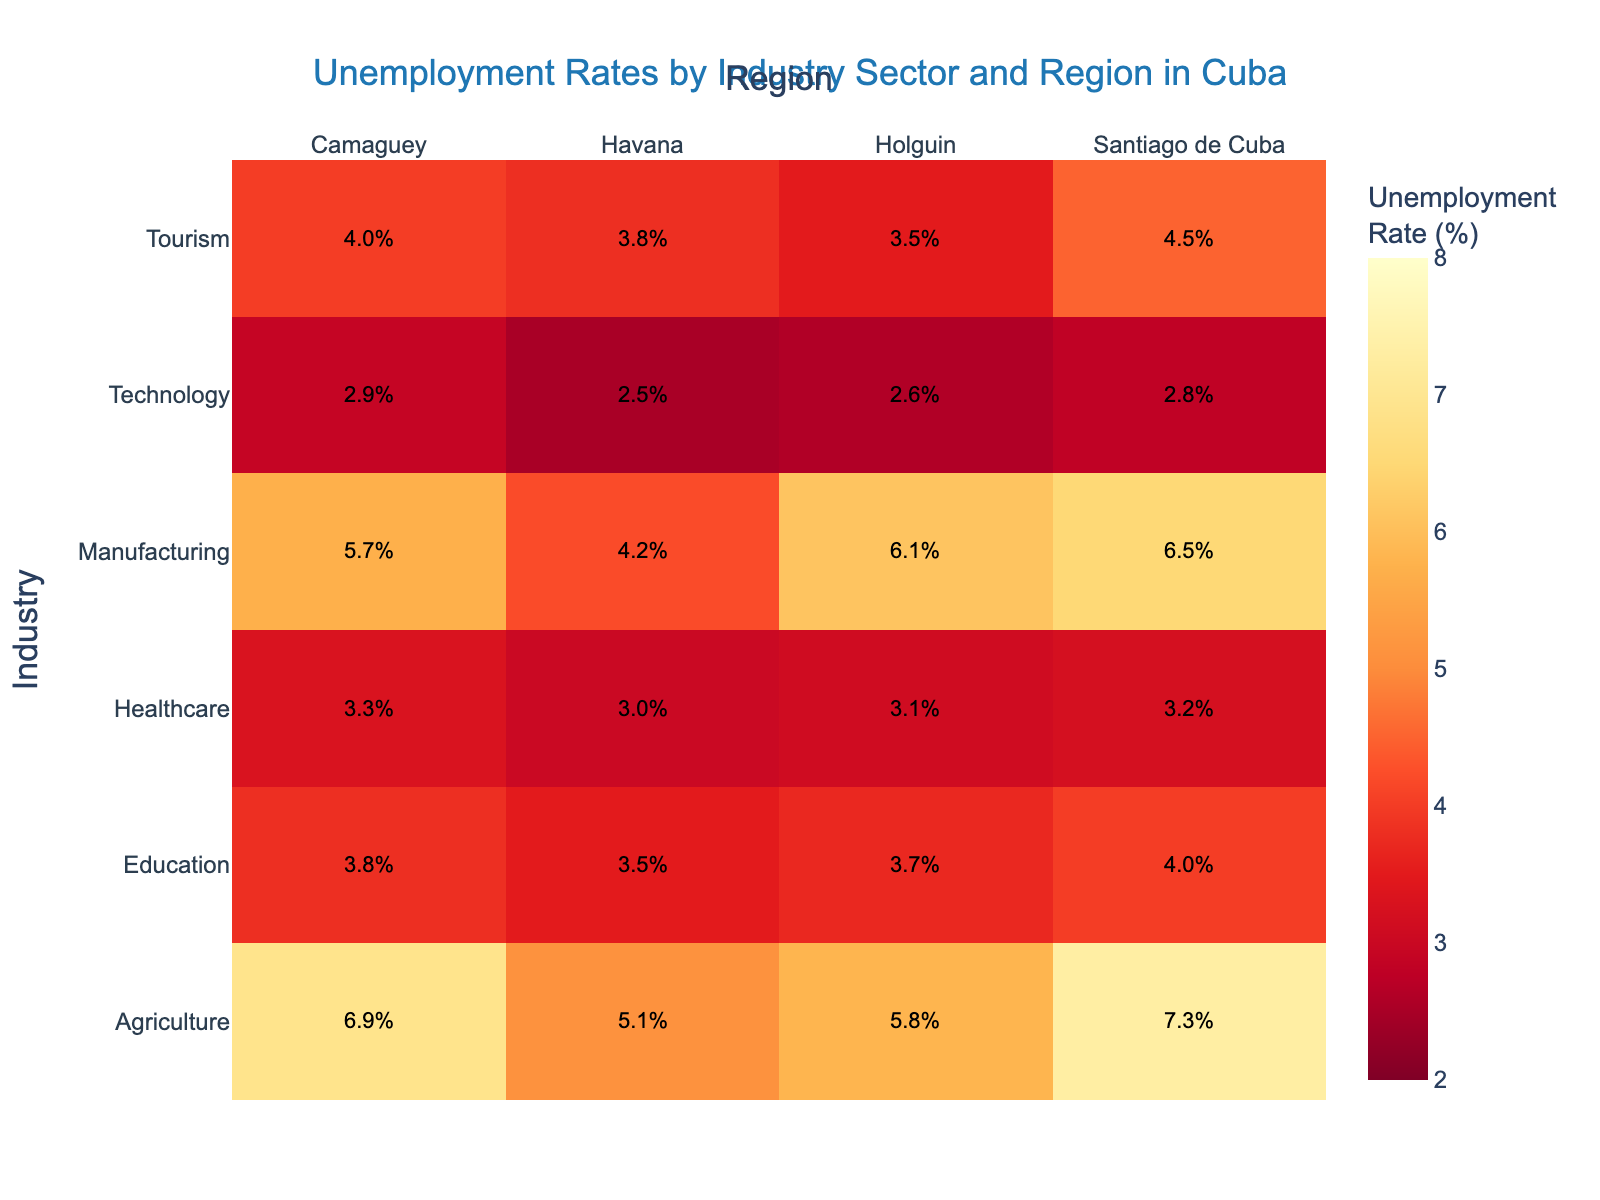What is the unemployment rate in the Technology sector in Santiago de Cuba? Look at the cell where the Industry is 'Technology' and the Region is 'Santiago de Cuba' in the heatmap, it shows the rate.
Answer: 2.8% Which industry sector in Havana has the highest unemployment rate? Check the 'Havana' column and identify the highest value among different industries. The highest value is in the 'Agriculture' row.
Answer: Agriculture Compare the unemployment rates in the Tourism sector between Holguin and Santiago de Cuba. Which one is higher? Locate the Tourism row and compare values in the 'Holguin' and 'Santiago de Cuba' columns. Santiago de Cuba has a higher unemployment rate than Holguin.
Answer: Santiago de Cuba What is the average unemployment rate in the Manufacturing sector across all regions? Identify the values for the Manufacturing sector across all regions and calculate the average: (4.2 + 6.5 + 5.7 + 6.1) / 4 = 5.625%
Answer: 5.625% Which region shows the lowest unemployment rate in the Healthcare sector? Look at the Healthcare row and find the minimum value. The lowest value is in 'Havana'.
Answer: Havana Is the unemployment rate in Agriculture higher in Camaguey or Holguin? Compare the values under the 'Agriculture' row for 'Camaguey' and 'Holguin'. Camaguey has a higher rate.
Answer: Camaguey Summing up the unemployment rates in the Technology sector, what is the total across all regions? Sum the values for Technology in all regions: 2.5 + 2.8 + 2.9 + 2.6 = 10.8%
Answer: 10.8% Which industry sector in Holguin has the lowest unemployment rate? Check the column for 'Holguin' and find the smallest value, which is in the Tourism sector.
Answer: Tourism Considering all sectors, which region has the most variation in unemployment rates? Compare the range of unemployment rates in each region. Santiago de Cuba shows the most variation, as it ranges from 2.8% to 7.3%.
Answer: Santiago de Cuba What is the difference in the unemployment rate between the highest and lowest sectors in Santiago de Cuba? Identify the highest and lowest unemployment values in Santiago de Cuba (7.3% and 2.8%, respectively), then compute their difference: 7.3% - 2.8% = 4.5%.
Answer: 4.5% 